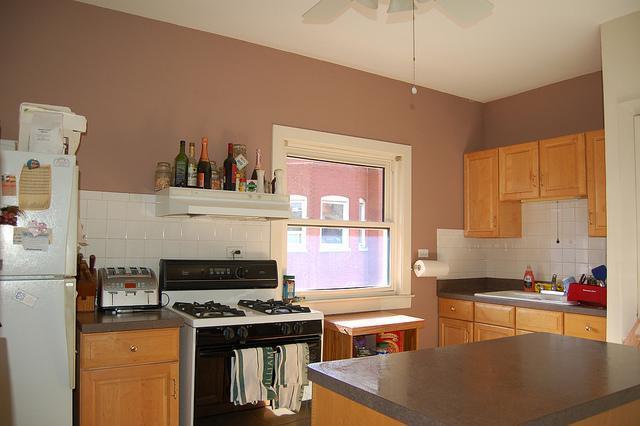How many people can be seen in the picture?
Give a very brief answer. 0. 